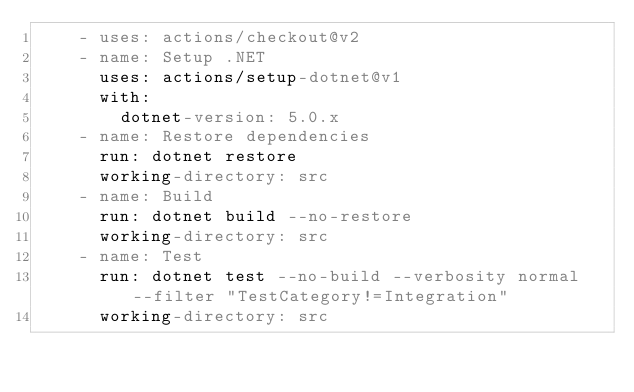Convert code to text. <code><loc_0><loc_0><loc_500><loc_500><_YAML_>    - uses: actions/checkout@v2
    - name: Setup .NET
      uses: actions/setup-dotnet@v1
      with:
        dotnet-version: 5.0.x
    - name: Restore dependencies
      run: dotnet restore
      working-directory: src
    - name: Build
      run: dotnet build --no-restore
      working-directory: src
    - name: Test
      run: dotnet test --no-build --verbosity normal --filter "TestCategory!=Integration"
      working-directory: src
</code> 